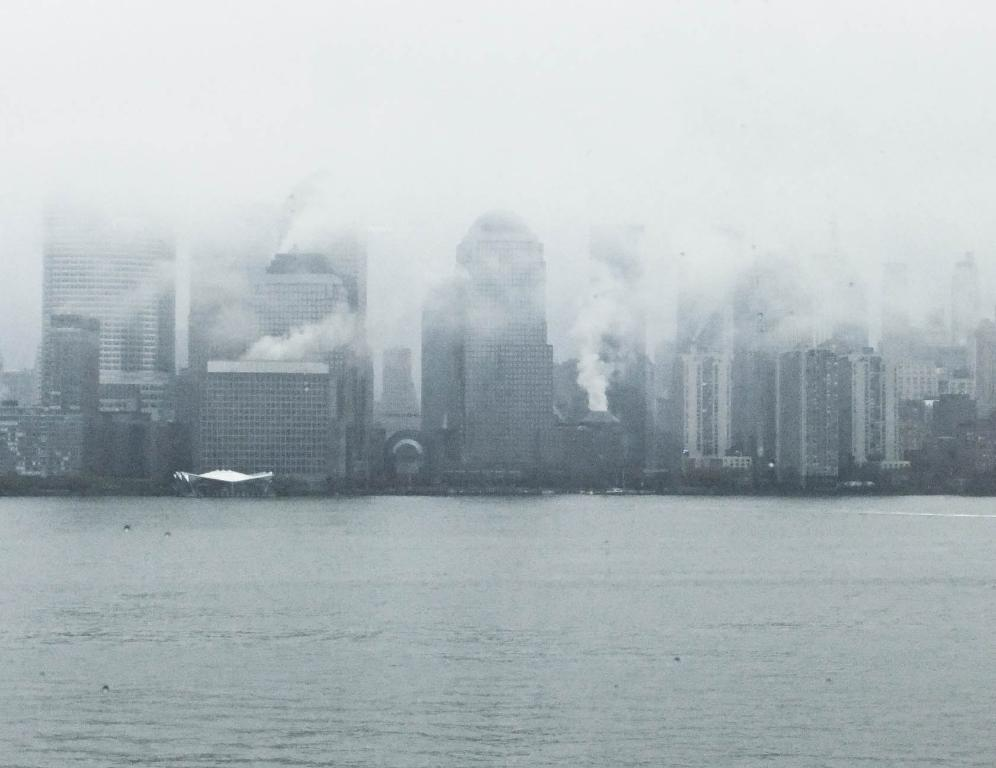What is in the foreground of the image? There is water in the front of the image. What can be seen in the distance in the image? There are buildings in the background of the image. What is the presence of in the image? There is smoke visible in the image. What is the name of the crow that is wearing a badge in the image? There is no crow or badge present in the image. What type of badge is the crow wearing in the image? There is no crow or badge present in the image. 